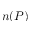<formula> <loc_0><loc_0><loc_500><loc_500>n ( P )</formula> 